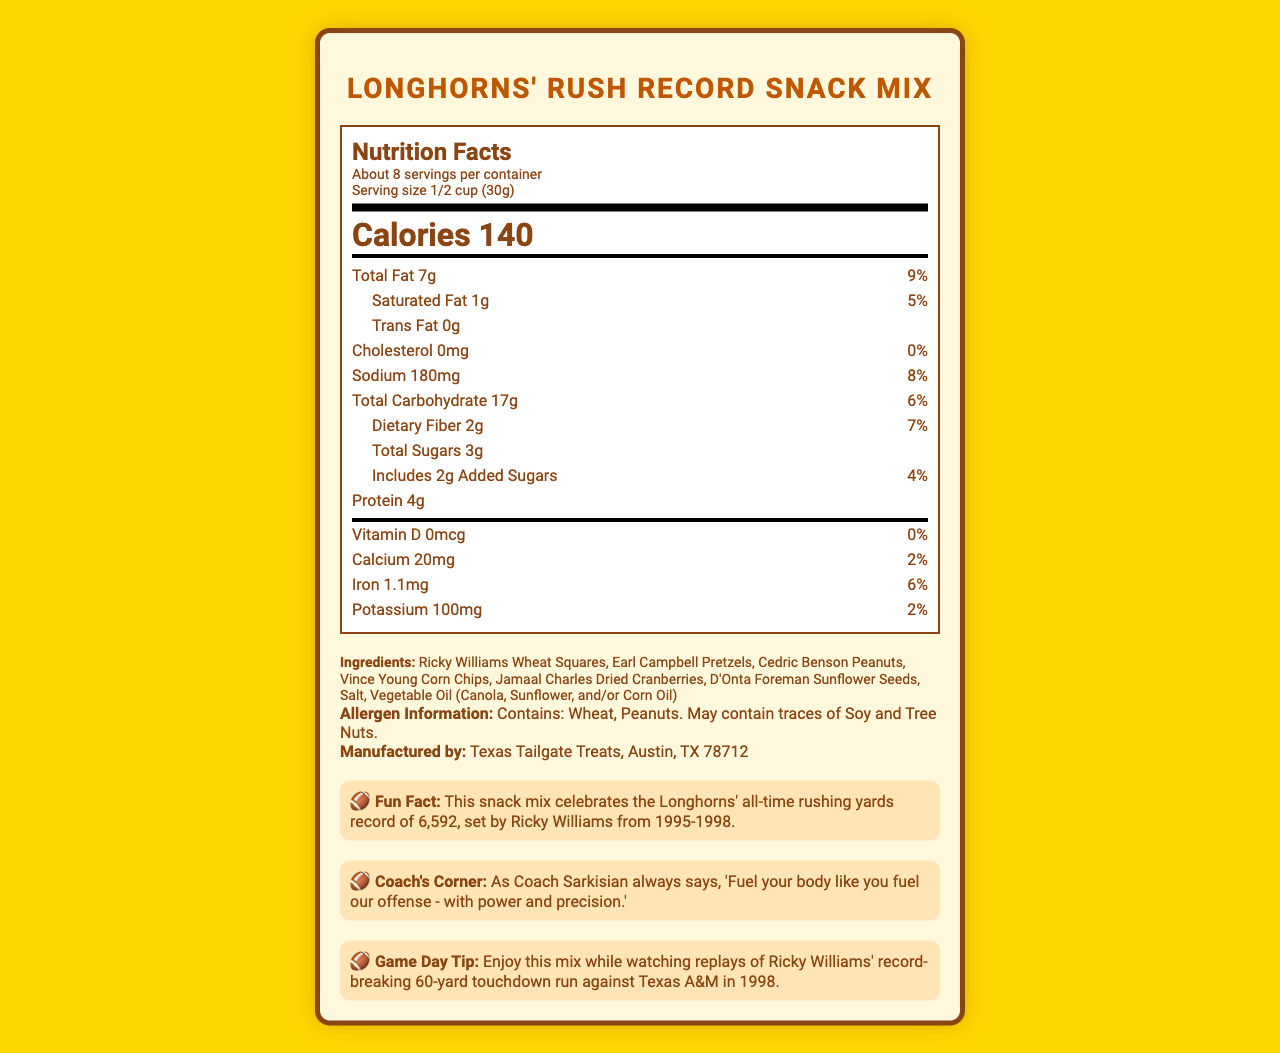what is the serving size of the Longhorns' Rush Record Snack Mix? The serving size is mentioned at the top part of the nutrition label under "Serving size."
Answer: 1/2 cup (30g) how many calories are in one serving of the snack mix? The number of calories per serving is displayed prominently in the center of the nutrition label.
Answer: 140 what is the amount of total fat per serving, and what percentage of the daily value does this represent? This information is listed under the "Total Fat" section of the nutrition label.
Answer: 7g, 9% how much sodium does one serving of the snack mix contain? The sodium content per serving is found under the "Sodium" section of the nutrition label.
Answer: 180mg which allergens are present in the Longhorns' Rush Record Snack Mix? The allergen information is located at the bottom of the document under "Allergen Information."
Answer: Wheat, Peanuts; May contain traces of Soy and Tree Nuts who manufactures the Longhorns' Rush Record Snack Mix? The manufacturer's information is provided near the bottom of the document.
Answer: Texas Tailgate Treats, Austin, TX 78712 how many grams of dietary fiber are in one serving of the snack mix? The dietary fiber content per serving is listed under "Total Carbohydrate" in the nutrition label.
Answer: 2g what does Coach Sarkisian say about fueling your body? This quote is found in the "Coach's Corner" section near the bottom of the document.
Answer: "Fuel your body like you fuel our offense - with power and precision." how does the fun fact relate to Ricky Williams? A. His total touchdowns B. His all-time rushing yards record C. His record-breaking pass completions D. His receiving yards The fun fact states that the snack mix celebrates Ricky Williams' all-time rushing yards record of 6,592.
Answer: B is the snack mix cholesterol-free? The nutrition label indicates that the cholesterol amount is 0mg, which is 0% of the daily value.
Answer: Yes summarize the document The document offers comprehensive nutritional data, brand story, and supplementary information to fans and consumers.
Answer: The document presents the Nutrition Facts for the "Longhorns' Rush Record Snack Mix," highlighting key nutritional information per serving, including calories, fats, sodium, carbohydrates, and protein. It lists the ingredients, allergens, manufacturer, and adds a fun fact about Ricky Williams' all-time rushing yards record. Additional sections include a quote from Coach Sarkisian and a game day tip. what are the Longhorns' total rushing yards record? While the fun fact mentions Ricky Williams' all-time rushing yards record, it does not offer the total rushing yards record for all Longhorns players combined.
Answer: Cannot be determined 